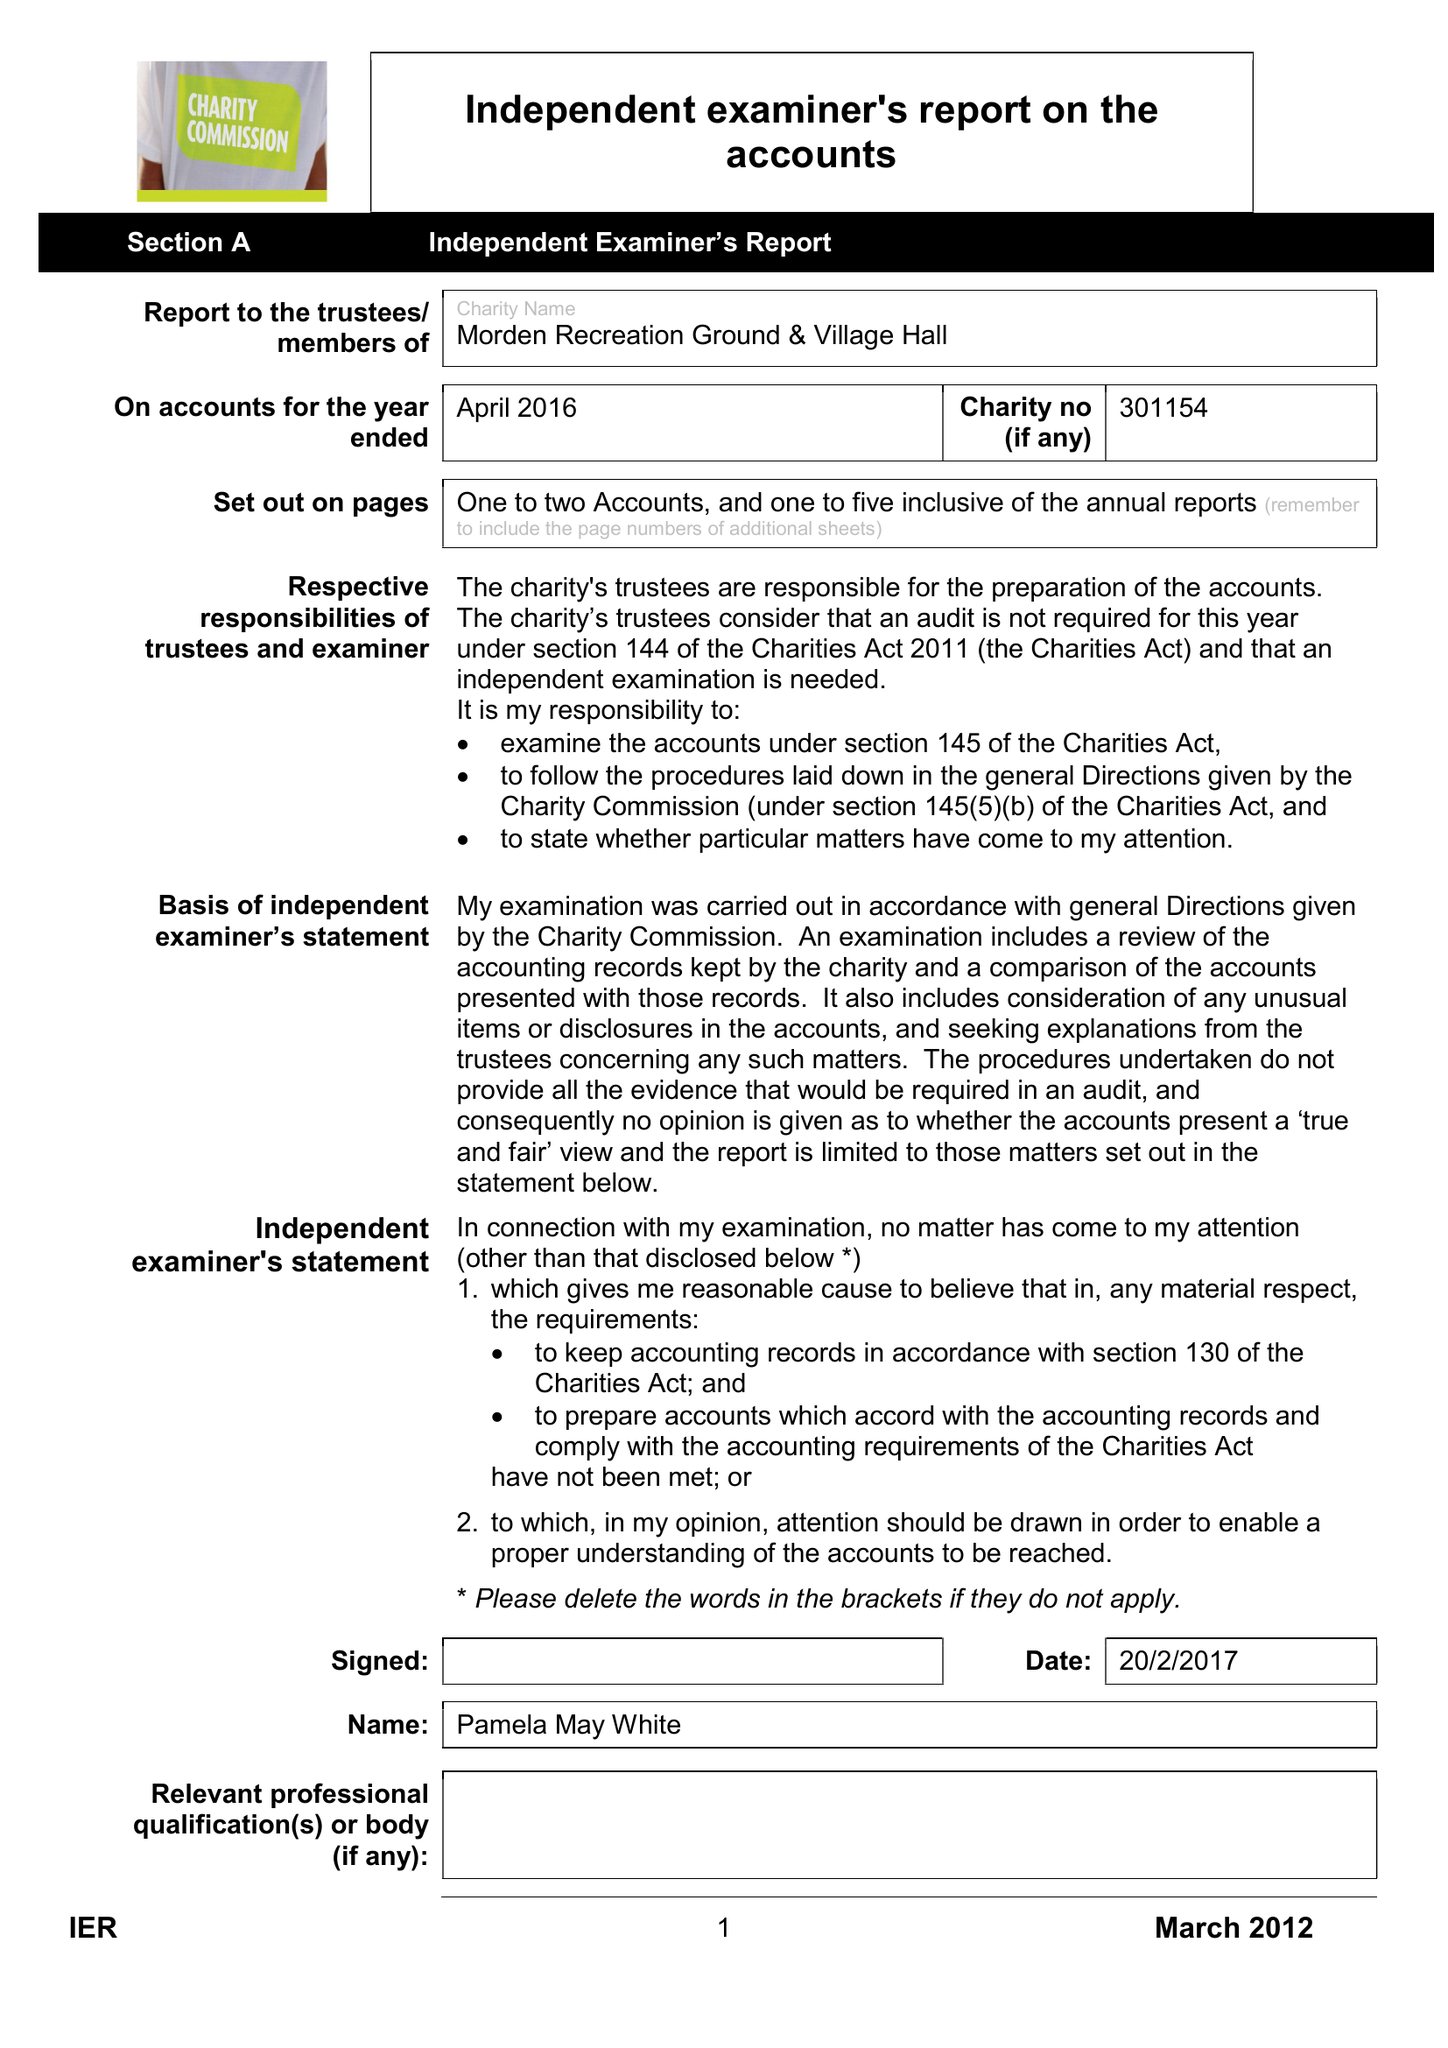What is the value for the address__postcode?
Answer the question using a single word or phrase. BH20 7EA 